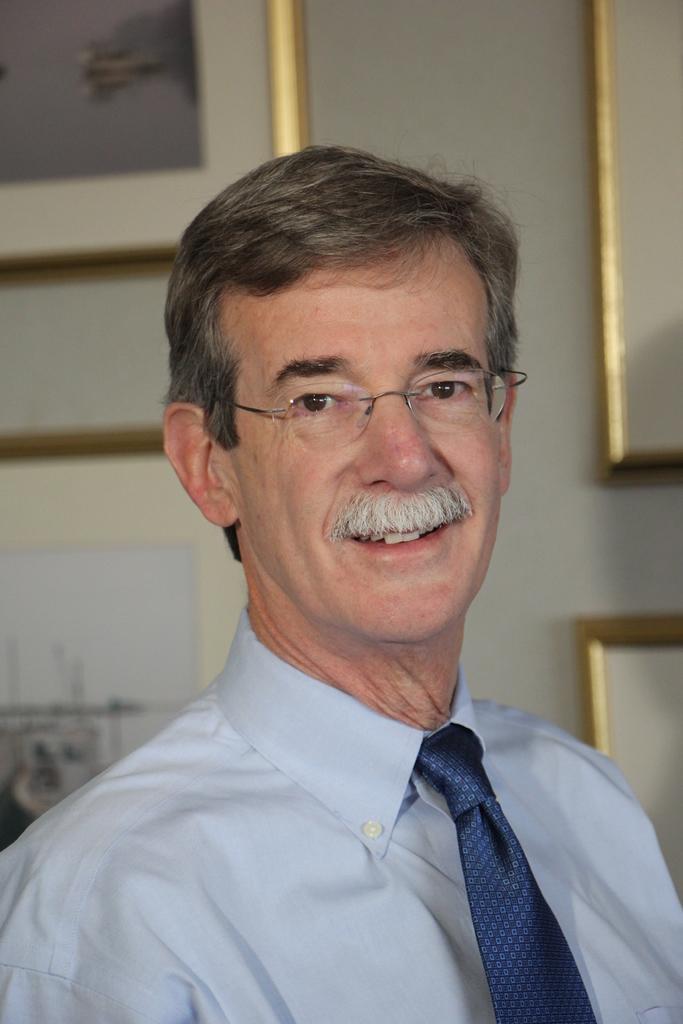Could you give a brief overview of what you see in this image? There is a man smiling and wore spectacle and tie. Background we can see frames on a wall. 